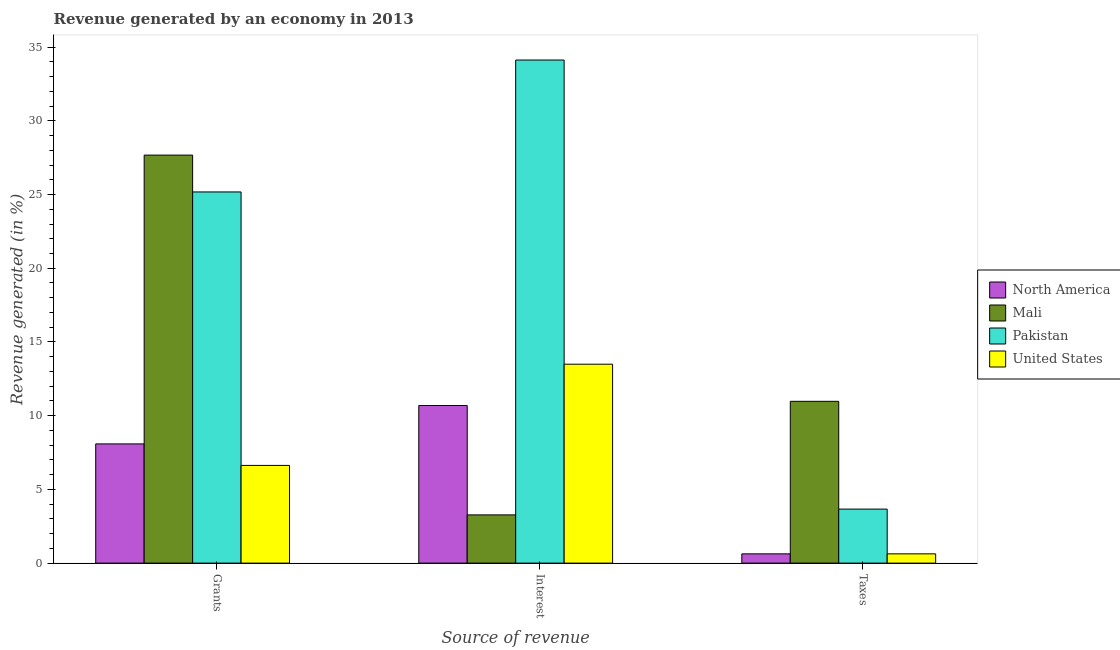Are the number of bars per tick equal to the number of legend labels?
Ensure brevity in your answer.  Yes. Are the number of bars on each tick of the X-axis equal?
Keep it short and to the point. Yes. What is the label of the 3rd group of bars from the left?
Your response must be concise. Taxes. What is the percentage of revenue generated by taxes in Mali?
Your answer should be compact. 10.97. Across all countries, what is the maximum percentage of revenue generated by grants?
Offer a terse response. 27.67. Across all countries, what is the minimum percentage of revenue generated by interest?
Offer a very short reply. 3.27. In which country was the percentage of revenue generated by taxes maximum?
Provide a short and direct response. Mali. In which country was the percentage of revenue generated by grants minimum?
Keep it short and to the point. United States. What is the total percentage of revenue generated by taxes in the graph?
Your answer should be very brief. 15.89. What is the difference between the percentage of revenue generated by grants in Mali and that in North America?
Ensure brevity in your answer.  19.59. What is the difference between the percentage of revenue generated by interest in North America and the percentage of revenue generated by grants in Mali?
Provide a short and direct response. -16.99. What is the average percentage of revenue generated by interest per country?
Offer a terse response. 15.39. What is the difference between the percentage of revenue generated by taxes and percentage of revenue generated by grants in North America?
Ensure brevity in your answer.  -7.46. What is the ratio of the percentage of revenue generated by interest in United States to that in North America?
Give a very brief answer. 1.26. Is the percentage of revenue generated by grants in North America less than that in United States?
Your answer should be compact. No. What is the difference between the highest and the second highest percentage of revenue generated by taxes?
Provide a succinct answer. 7.31. What is the difference between the highest and the lowest percentage of revenue generated by interest?
Provide a short and direct response. 30.85. In how many countries, is the percentage of revenue generated by grants greater than the average percentage of revenue generated by grants taken over all countries?
Offer a very short reply. 2. What does the 1st bar from the left in Taxes represents?
Make the answer very short. North America. What does the 3rd bar from the right in Taxes represents?
Offer a very short reply. Mali. How many countries are there in the graph?
Provide a short and direct response. 4. What is the difference between two consecutive major ticks on the Y-axis?
Provide a succinct answer. 5. Does the graph contain any zero values?
Make the answer very short. No. Does the graph contain grids?
Your response must be concise. No. Where does the legend appear in the graph?
Your answer should be compact. Center right. How are the legend labels stacked?
Make the answer very short. Vertical. What is the title of the graph?
Your answer should be compact. Revenue generated by an economy in 2013. Does "Czech Republic" appear as one of the legend labels in the graph?
Your response must be concise. No. What is the label or title of the X-axis?
Offer a very short reply. Source of revenue. What is the label or title of the Y-axis?
Ensure brevity in your answer.  Revenue generated (in %). What is the Revenue generated (in %) of North America in Grants?
Make the answer very short. 8.09. What is the Revenue generated (in %) in Mali in Grants?
Ensure brevity in your answer.  27.67. What is the Revenue generated (in %) in Pakistan in Grants?
Ensure brevity in your answer.  25.18. What is the Revenue generated (in %) of United States in Grants?
Make the answer very short. 6.63. What is the Revenue generated (in %) of North America in Interest?
Provide a succinct answer. 10.69. What is the Revenue generated (in %) of Mali in Interest?
Provide a succinct answer. 3.27. What is the Revenue generated (in %) of Pakistan in Interest?
Offer a very short reply. 34.12. What is the Revenue generated (in %) of United States in Interest?
Provide a succinct answer. 13.49. What is the Revenue generated (in %) of North America in Taxes?
Offer a very short reply. 0.63. What is the Revenue generated (in %) in Mali in Taxes?
Ensure brevity in your answer.  10.97. What is the Revenue generated (in %) of Pakistan in Taxes?
Keep it short and to the point. 3.66. What is the Revenue generated (in %) in United States in Taxes?
Offer a very short reply. 0.63. Across all Source of revenue, what is the maximum Revenue generated (in %) of North America?
Give a very brief answer. 10.69. Across all Source of revenue, what is the maximum Revenue generated (in %) of Mali?
Offer a very short reply. 27.67. Across all Source of revenue, what is the maximum Revenue generated (in %) in Pakistan?
Keep it short and to the point. 34.12. Across all Source of revenue, what is the maximum Revenue generated (in %) in United States?
Provide a succinct answer. 13.49. Across all Source of revenue, what is the minimum Revenue generated (in %) of North America?
Your response must be concise. 0.63. Across all Source of revenue, what is the minimum Revenue generated (in %) of Mali?
Your answer should be very brief. 3.27. Across all Source of revenue, what is the minimum Revenue generated (in %) in Pakistan?
Give a very brief answer. 3.66. Across all Source of revenue, what is the minimum Revenue generated (in %) in United States?
Your answer should be compact. 0.63. What is the total Revenue generated (in %) of North America in the graph?
Ensure brevity in your answer.  19.4. What is the total Revenue generated (in %) in Mali in the graph?
Make the answer very short. 41.92. What is the total Revenue generated (in %) in Pakistan in the graph?
Your response must be concise. 62.96. What is the total Revenue generated (in %) in United States in the graph?
Offer a very short reply. 20.75. What is the difference between the Revenue generated (in %) in North America in Grants and that in Interest?
Provide a short and direct response. -2.6. What is the difference between the Revenue generated (in %) in Mali in Grants and that in Interest?
Offer a very short reply. 24.4. What is the difference between the Revenue generated (in %) in Pakistan in Grants and that in Interest?
Offer a terse response. -8.95. What is the difference between the Revenue generated (in %) in United States in Grants and that in Interest?
Your answer should be compact. -6.87. What is the difference between the Revenue generated (in %) in North America in Grants and that in Taxes?
Make the answer very short. 7.46. What is the difference between the Revenue generated (in %) of Mali in Grants and that in Taxes?
Keep it short and to the point. 16.7. What is the difference between the Revenue generated (in %) of Pakistan in Grants and that in Taxes?
Give a very brief answer. 21.51. What is the difference between the Revenue generated (in %) in United States in Grants and that in Taxes?
Ensure brevity in your answer.  6. What is the difference between the Revenue generated (in %) of North America in Interest and that in Taxes?
Your response must be concise. 10.06. What is the difference between the Revenue generated (in %) of Mali in Interest and that in Taxes?
Ensure brevity in your answer.  -7.7. What is the difference between the Revenue generated (in %) of Pakistan in Interest and that in Taxes?
Offer a terse response. 30.46. What is the difference between the Revenue generated (in %) of United States in Interest and that in Taxes?
Provide a short and direct response. 12.86. What is the difference between the Revenue generated (in %) in North America in Grants and the Revenue generated (in %) in Mali in Interest?
Make the answer very short. 4.81. What is the difference between the Revenue generated (in %) of North America in Grants and the Revenue generated (in %) of Pakistan in Interest?
Your answer should be compact. -26.04. What is the difference between the Revenue generated (in %) in North America in Grants and the Revenue generated (in %) in United States in Interest?
Your answer should be compact. -5.41. What is the difference between the Revenue generated (in %) in Mali in Grants and the Revenue generated (in %) in Pakistan in Interest?
Ensure brevity in your answer.  -6.45. What is the difference between the Revenue generated (in %) in Mali in Grants and the Revenue generated (in %) in United States in Interest?
Offer a terse response. 14.18. What is the difference between the Revenue generated (in %) in Pakistan in Grants and the Revenue generated (in %) in United States in Interest?
Provide a short and direct response. 11.68. What is the difference between the Revenue generated (in %) of North America in Grants and the Revenue generated (in %) of Mali in Taxes?
Your answer should be compact. -2.89. What is the difference between the Revenue generated (in %) of North America in Grants and the Revenue generated (in %) of Pakistan in Taxes?
Offer a terse response. 4.42. What is the difference between the Revenue generated (in %) of North America in Grants and the Revenue generated (in %) of United States in Taxes?
Ensure brevity in your answer.  7.46. What is the difference between the Revenue generated (in %) in Mali in Grants and the Revenue generated (in %) in Pakistan in Taxes?
Keep it short and to the point. 24.01. What is the difference between the Revenue generated (in %) in Mali in Grants and the Revenue generated (in %) in United States in Taxes?
Your answer should be very brief. 27.05. What is the difference between the Revenue generated (in %) in Pakistan in Grants and the Revenue generated (in %) in United States in Taxes?
Ensure brevity in your answer.  24.55. What is the difference between the Revenue generated (in %) in North America in Interest and the Revenue generated (in %) in Mali in Taxes?
Make the answer very short. -0.28. What is the difference between the Revenue generated (in %) in North America in Interest and the Revenue generated (in %) in Pakistan in Taxes?
Keep it short and to the point. 7.03. What is the difference between the Revenue generated (in %) in North America in Interest and the Revenue generated (in %) in United States in Taxes?
Provide a short and direct response. 10.06. What is the difference between the Revenue generated (in %) of Mali in Interest and the Revenue generated (in %) of Pakistan in Taxes?
Your answer should be very brief. -0.39. What is the difference between the Revenue generated (in %) of Mali in Interest and the Revenue generated (in %) of United States in Taxes?
Your answer should be very brief. 2.64. What is the difference between the Revenue generated (in %) of Pakistan in Interest and the Revenue generated (in %) of United States in Taxes?
Give a very brief answer. 33.49. What is the average Revenue generated (in %) of North America per Source of revenue?
Ensure brevity in your answer.  6.47. What is the average Revenue generated (in %) of Mali per Source of revenue?
Provide a short and direct response. 13.97. What is the average Revenue generated (in %) in Pakistan per Source of revenue?
Your answer should be compact. 20.99. What is the average Revenue generated (in %) of United States per Source of revenue?
Provide a succinct answer. 6.92. What is the difference between the Revenue generated (in %) in North America and Revenue generated (in %) in Mali in Grants?
Make the answer very short. -19.59. What is the difference between the Revenue generated (in %) in North America and Revenue generated (in %) in Pakistan in Grants?
Offer a very short reply. -17.09. What is the difference between the Revenue generated (in %) of North America and Revenue generated (in %) of United States in Grants?
Your answer should be compact. 1.46. What is the difference between the Revenue generated (in %) in Mali and Revenue generated (in %) in Pakistan in Grants?
Give a very brief answer. 2.5. What is the difference between the Revenue generated (in %) of Mali and Revenue generated (in %) of United States in Grants?
Your response must be concise. 21.05. What is the difference between the Revenue generated (in %) of Pakistan and Revenue generated (in %) of United States in Grants?
Keep it short and to the point. 18.55. What is the difference between the Revenue generated (in %) in North America and Revenue generated (in %) in Mali in Interest?
Your response must be concise. 7.42. What is the difference between the Revenue generated (in %) of North America and Revenue generated (in %) of Pakistan in Interest?
Offer a terse response. -23.43. What is the difference between the Revenue generated (in %) of North America and Revenue generated (in %) of United States in Interest?
Your answer should be very brief. -2.8. What is the difference between the Revenue generated (in %) of Mali and Revenue generated (in %) of Pakistan in Interest?
Ensure brevity in your answer.  -30.85. What is the difference between the Revenue generated (in %) in Mali and Revenue generated (in %) in United States in Interest?
Offer a terse response. -10.22. What is the difference between the Revenue generated (in %) in Pakistan and Revenue generated (in %) in United States in Interest?
Offer a very short reply. 20.63. What is the difference between the Revenue generated (in %) in North America and Revenue generated (in %) in Mali in Taxes?
Your response must be concise. -10.34. What is the difference between the Revenue generated (in %) of North America and Revenue generated (in %) of Pakistan in Taxes?
Your answer should be compact. -3.03. What is the difference between the Revenue generated (in %) in Mali and Revenue generated (in %) in Pakistan in Taxes?
Provide a succinct answer. 7.31. What is the difference between the Revenue generated (in %) of Mali and Revenue generated (in %) of United States in Taxes?
Give a very brief answer. 10.34. What is the difference between the Revenue generated (in %) of Pakistan and Revenue generated (in %) of United States in Taxes?
Provide a short and direct response. 3.03. What is the ratio of the Revenue generated (in %) in North America in Grants to that in Interest?
Your answer should be very brief. 0.76. What is the ratio of the Revenue generated (in %) of Mali in Grants to that in Interest?
Offer a very short reply. 8.46. What is the ratio of the Revenue generated (in %) in Pakistan in Grants to that in Interest?
Your answer should be very brief. 0.74. What is the ratio of the Revenue generated (in %) of United States in Grants to that in Interest?
Your response must be concise. 0.49. What is the ratio of the Revenue generated (in %) in North America in Grants to that in Taxes?
Keep it short and to the point. 12.86. What is the ratio of the Revenue generated (in %) in Mali in Grants to that in Taxes?
Make the answer very short. 2.52. What is the ratio of the Revenue generated (in %) in Pakistan in Grants to that in Taxes?
Provide a short and direct response. 6.87. What is the ratio of the Revenue generated (in %) of United States in Grants to that in Taxes?
Ensure brevity in your answer.  10.54. What is the ratio of the Revenue generated (in %) of North America in Interest to that in Taxes?
Your answer should be compact. 17. What is the ratio of the Revenue generated (in %) of Mali in Interest to that in Taxes?
Offer a terse response. 0.3. What is the ratio of the Revenue generated (in %) in Pakistan in Interest to that in Taxes?
Your answer should be compact. 9.31. What is the ratio of the Revenue generated (in %) of United States in Interest to that in Taxes?
Give a very brief answer. 21.46. What is the difference between the highest and the second highest Revenue generated (in %) of North America?
Make the answer very short. 2.6. What is the difference between the highest and the second highest Revenue generated (in %) in Mali?
Provide a succinct answer. 16.7. What is the difference between the highest and the second highest Revenue generated (in %) in Pakistan?
Give a very brief answer. 8.95. What is the difference between the highest and the second highest Revenue generated (in %) in United States?
Keep it short and to the point. 6.87. What is the difference between the highest and the lowest Revenue generated (in %) in North America?
Ensure brevity in your answer.  10.06. What is the difference between the highest and the lowest Revenue generated (in %) in Mali?
Offer a very short reply. 24.4. What is the difference between the highest and the lowest Revenue generated (in %) of Pakistan?
Give a very brief answer. 30.46. What is the difference between the highest and the lowest Revenue generated (in %) in United States?
Offer a terse response. 12.86. 